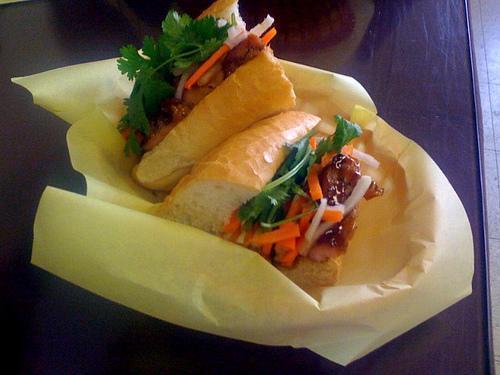How many individual sandwich pieces are in the image?
Answer the question by selecting the correct answer among the 4 following choices and explain your choice with a short sentence. The answer should be formatted with the following format: `Answer: choice
Rationale: rationale.`
Options: Four, seven, nine, two. Answer: two.
Rationale: The sandwich is very colorful. 